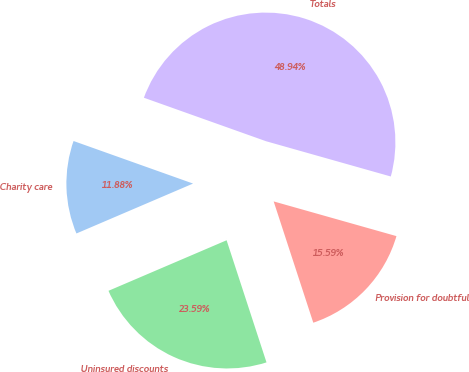Convert chart to OTSL. <chart><loc_0><loc_0><loc_500><loc_500><pie_chart><fcel>Charity care<fcel>Uninsured discounts<fcel>Provision for doubtful<fcel>Totals<nl><fcel>11.88%<fcel>23.59%<fcel>15.59%<fcel>48.94%<nl></chart> 